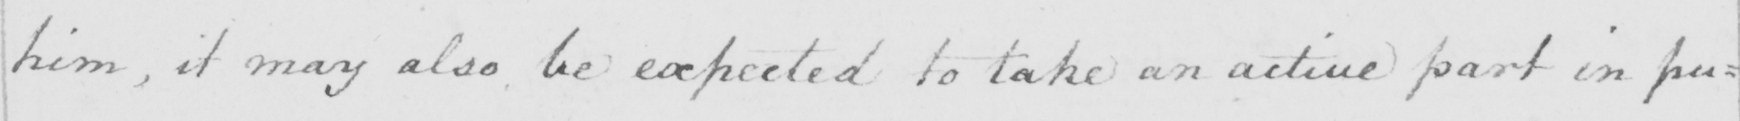What is written in this line of handwriting? him , it may also be expected to take an active part in pu= 